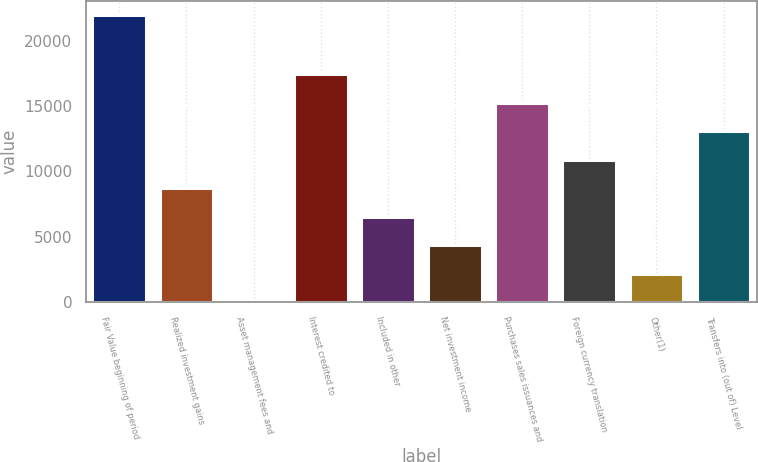Convert chart to OTSL. <chart><loc_0><loc_0><loc_500><loc_500><bar_chart><fcel>Fair Value beginning of period<fcel>Realized investment gains<fcel>Asset management fees and<fcel>Interest credited to<fcel>Included in other<fcel>Net investment income<fcel>Purchases sales issuances and<fcel>Foreign currency translation<fcel>Other(1)<fcel>Transfers into (out of) Level<nl><fcel>21961.3<fcel>8727.11<fcel>1.85<fcel>17452.4<fcel>6545.8<fcel>4364.48<fcel>15271.1<fcel>10908.4<fcel>2183.16<fcel>13089.8<nl></chart> 